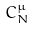Convert formula to latex. <formula><loc_0><loc_0><loc_500><loc_500>C _ { N } ^ { \mu }</formula> 